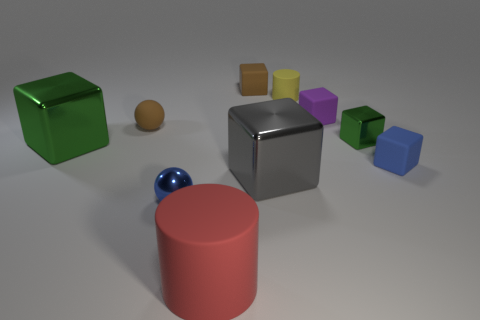What is the shape of the big shiny thing that is on the right side of the large green metal block?
Ensure brevity in your answer.  Cube. How many tiny brown rubber objects are both in front of the small brown matte cube and behind the brown sphere?
Keep it short and to the point. 0. What number of other things are there of the same size as the red matte cylinder?
Your response must be concise. 2. Is the shape of the green shiny object to the right of the tiny blue ball the same as the brown object that is in front of the small yellow rubber cylinder?
Provide a short and direct response. No. What number of objects are either small yellow matte cylinders or small blue objects that are to the right of the small blue metallic sphere?
Provide a succinct answer. 2. There is a object that is in front of the blue cube and to the left of the large red rubber cylinder; what material is it?
Give a very brief answer. Metal. Is there any other thing that is the same shape as the yellow object?
Your answer should be very brief. Yes. What color is the ball that is made of the same material as the tiny yellow thing?
Your answer should be compact. Brown. What number of things are big gray cubes or red things?
Provide a succinct answer. 2. Is the size of the blue metal sphere the same as the green shiny block that is to the left of the gray metallic thing?
Provide a succinct answer. No. 